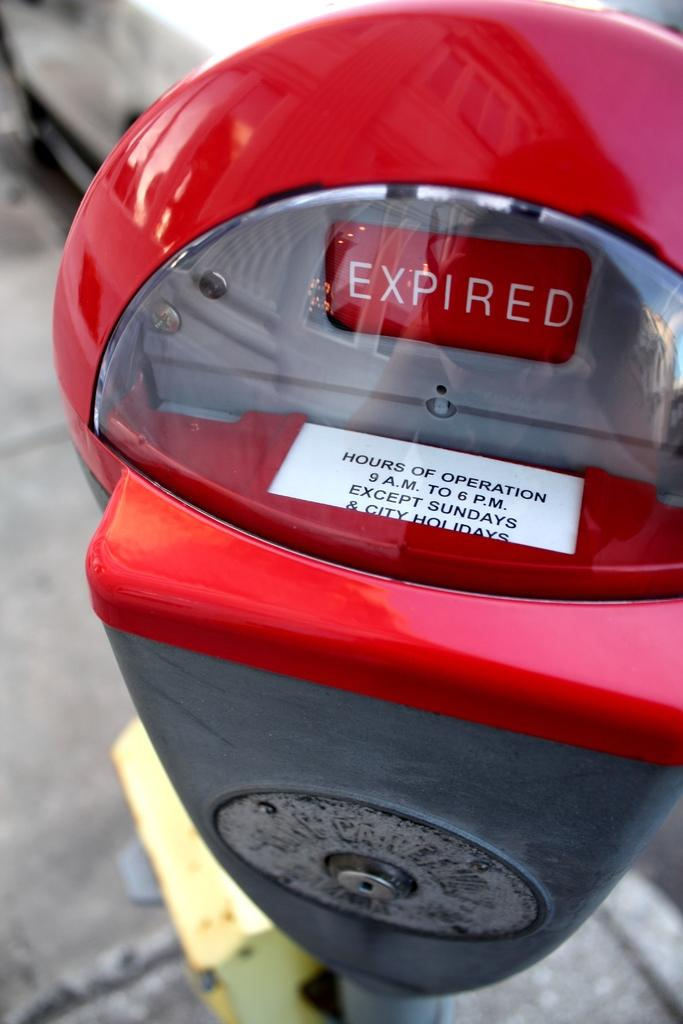<image>
Summarize the visual content of the image. A red parking meter says Expired and Hours of Operation. 